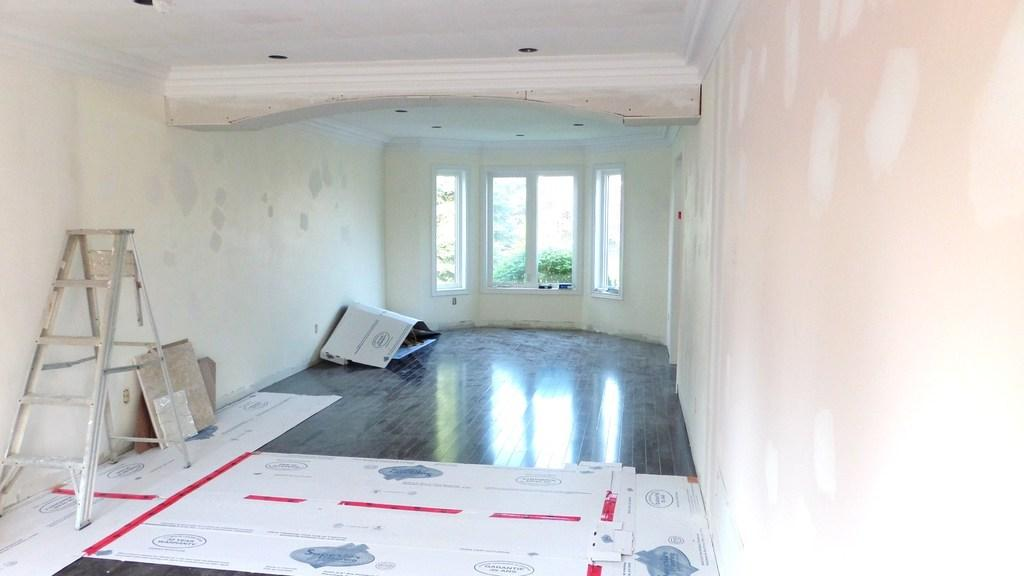What type of space is shown in the image? The image is an inside view of a room. What is the primary surface on which people can stand or walk in the room? There is a floor in the room. What materials are present in the room for storage or organization? There are cardboards in the room. What is used for reaching higher areas in the room? There is a ladder in the room. What encloses the space and provides structural support? The room has walls and a roof. What allows natural light and a view of the outdoors in the room? There is a window in the room. What can be seen outside the window in the image? Greenery is visible through the window. What type of bells can be heard ringing in the room? There are no bells present in the image, and therefore no sound can be heard. 